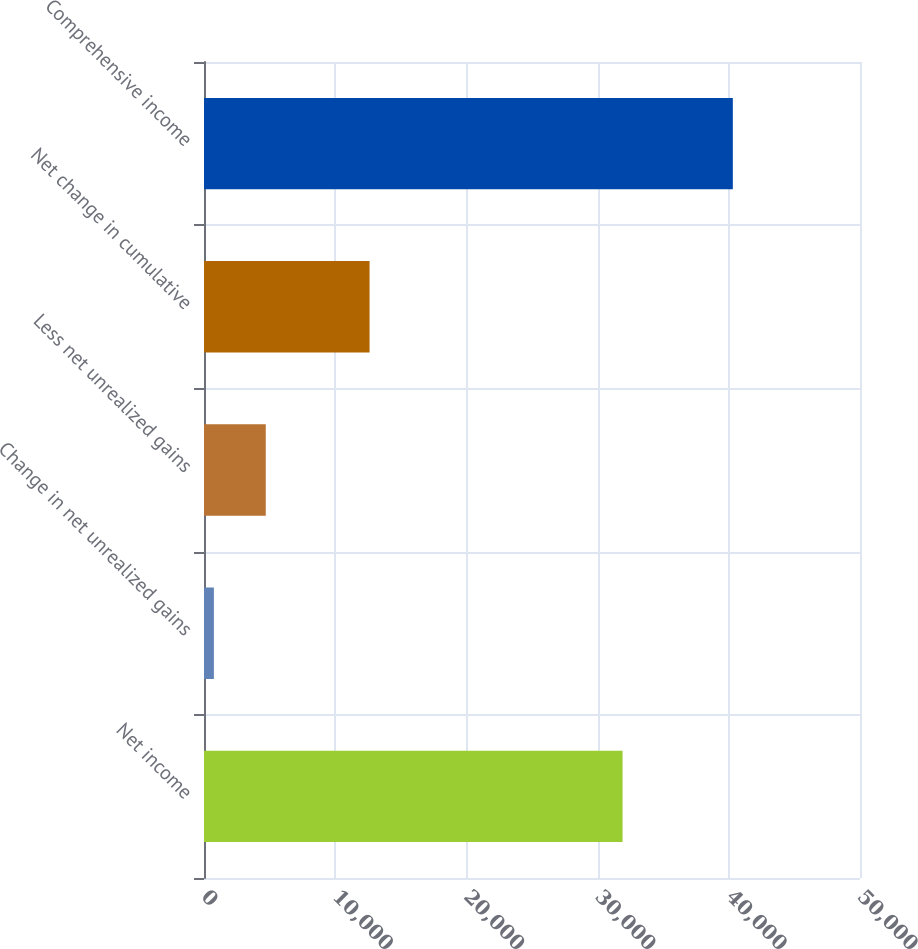Convert chart to OTSL. <chart><loc_0><loc_0><loc_500><loc_500><bar_chart><fcel>Net income<fcel>Change in net unrealized gains<fcel>Less net unrealized gains<fcel>Net change in cumulative<fcel>Comprehensive income<nl><fcel>31904<fcel>753<fcel>4708.5<fcel>12619.5<fcel>40308<nl></chart> 